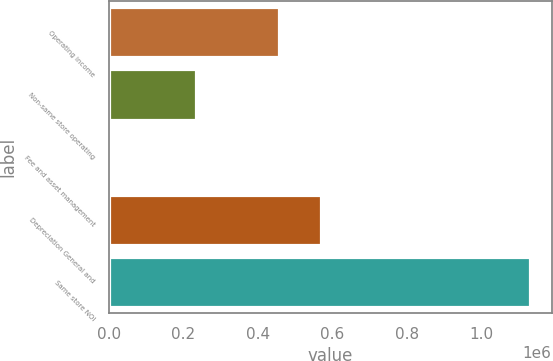Convert chart to OTSL. <chart><loc_0><loc_0><loc_500><loc_500><bar_chart><fcel>Operating income<fcel>Non-same store operating<fcel>Fee and asset management<fcel>Depreciation General and<fcel>Same store NOI<nl><fcel>458158<fcel>232997<fcel>7981<fcel>570666<fcel>1.13306e+06<nl></chart> 